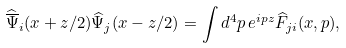Convert formula to latex. <formula><loc_0><loc_0><loc_500><loc_500>\widehat { \overline { \Psi } } _ { i } ( x + z / 2 ) \widehat { \Psi } _ { j } ( x - z / 2 ) = \int d ^ { 4 } p \, e ^ { i p z } \widehat { F } _ { j i } ( x , p ) ,</formula> 